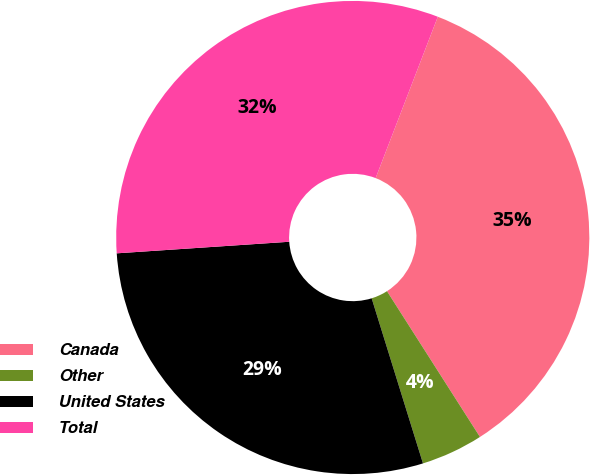Convert chart to OTSL. <chart><loc_0><loc_0><loc_500><loc_500><pie_chart><fcel>Canada<fcel>Other<fcel>United States<fcel>Total<nl><fcel>35.11%<fcel>4.24%<fcel>28.73%<fcel>31.92%<nl></chart> 